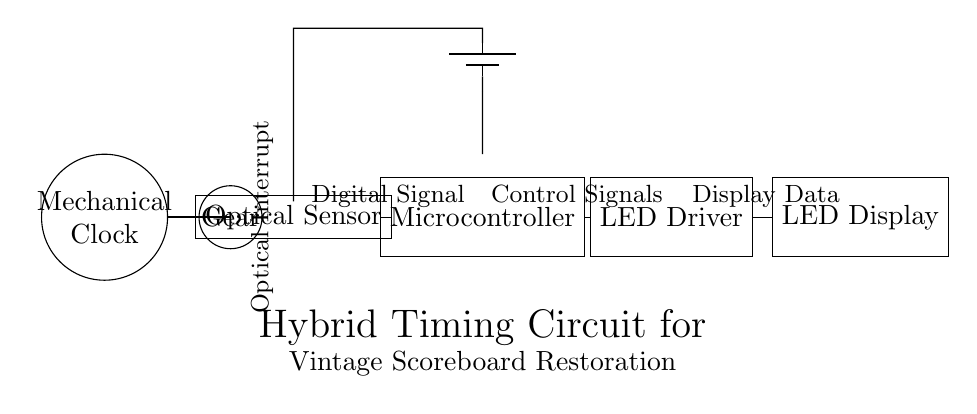What is the main component of the timing circuit? The main component is the mechanical clock, which initiates the timing sequence in the circuit.
Answer: Mechanical clock What does the optical sensor do? The optical sensor detects the movement of the mechanical clock's gears, converting mechanical motion into a digital signal that can be processed.
Answer: Digital signal How many major components are connected in this circuit? There are four major components connected: the mechanical clock, optical sensor, microcontroller, and LED display driver.
Answer: Four What is the purpose of the microcontroller? The microcontroller processes the digital signals from the optical sensor and controls the LED display driver.
Answer: Control signals What type of display is used in this circuit? The display type used in this circuit is an LED display, which shows the score visually.
Answer: LED display Explain the interaction between the optical sensor and the microcontroller. The optical sensor outputs a digital signal indicating gear movement, which the microcontroller interprets to provide timing or scoring information for the display. This connection allows the mechanical timing from the clock to translate into electronic controls for the scoreboard.
Answer: Digital signal What kind of power supply is in the circuit? The power supply in the circuit is a battery, which provides the necessary voltage for the components to operate.
Answer: Battery 